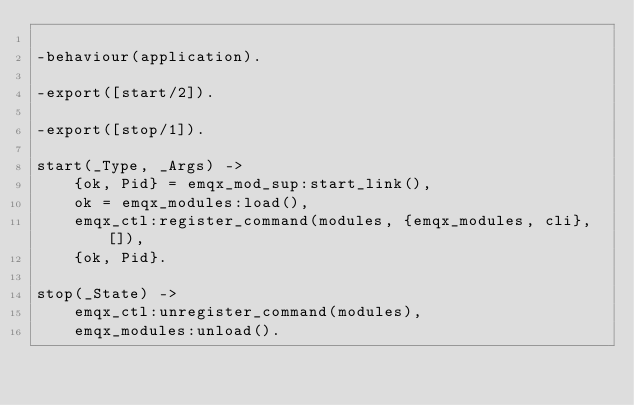Convert code to text. <code><loc_0><loc_0><loc_500><loc_500><_Erlang_>
-behaviour(application).

-export([start/2]).

-export([stop/1]).

start(_Type, _Args) ->
    {ok, Pid} = emqx_mod_sup:start_link(),
    ok = emqx_modules:load(),
    emqx_ctl:register_command(modules, {emqx_modules, cli}, []),
    {ok, Pid}.

stop(_State) ->
    emqx_ctl:unregister_command(modules),
    emqx_modules:unload().
</code> 